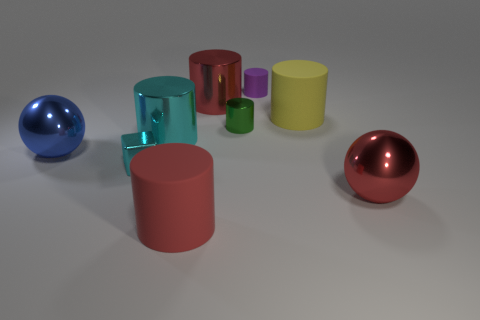What size is the red thing that is in front of the large blue thing and left of the big red sphere?
Ensure brevity in your answer.  Large. There is a cylinder that is the same color as the cube; what size is it?
Keep it short and to the point. Large. Are there any large cylinders that have the same color as the small metallic cube?
Provide a short and direct response. Yes. What shape is the large shiny object that is the same color as the tiny block?
Offer a terse response. Cylinder. There is a red metallic thing that is the same size as the red metallic cylinder; what shape is it?
Offer a very short reply. Sphere. There is a tiny metallic object that is the same shape as the red rubber thing; what is its color?
Make the answer very short. Green. How many things are tiny objects or tiny cyan cubes?
Keep it short and to the point. 3. Do the big red metallic object in front of the small metallic cylinder and the shiny object that is to the left of the tiny cyan shiny cube have the same shape?
Offer a very short reply. Yes. The small thing that is left of the green cylinder has what shape?
Make the answer very short. Cube. Are there the same number of tiny matte objects left of the blue shiny thing and red spheres behind the small cyan metallic cube?
Your answer should be compact. Yes. 